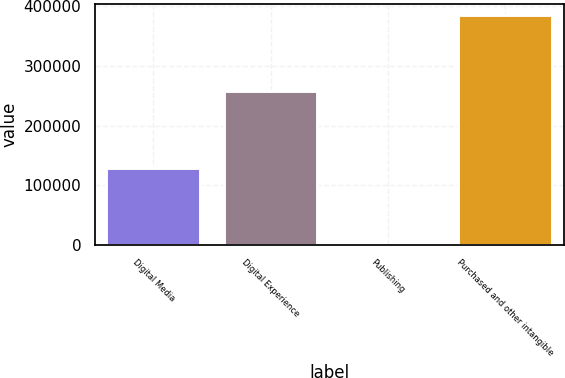Convert chart to OTSL. <chart><loc_0><loc_0><loc_500><loc_500><bar_chart><fcel>Digital Media<fcel>Digital Experience<fcel>Publishing<fcel>Purchased and other intangible<nl><fcel>128243<fcel>257408<fcel>7<fcel>385658<nl></chart> 